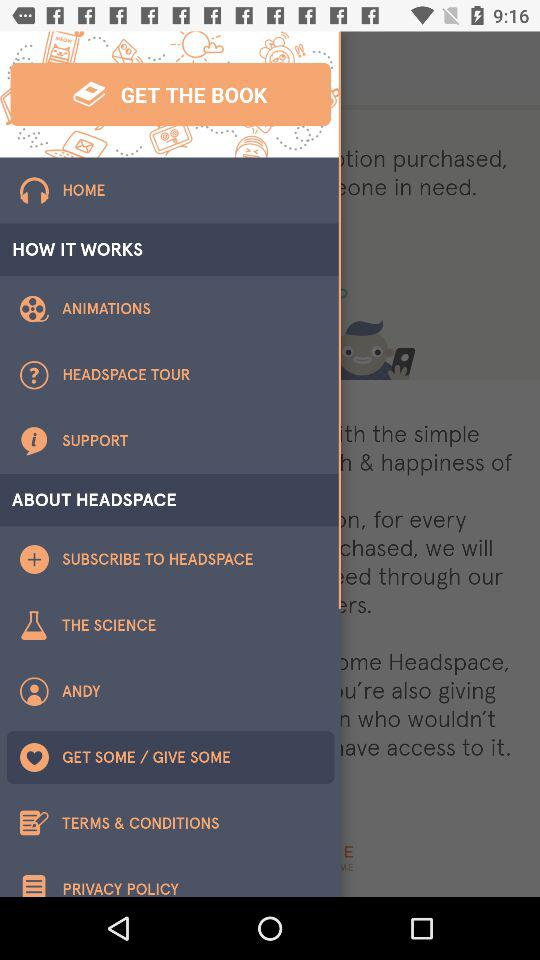What is the name of the application? The name of the application is "HEADSPACE". 